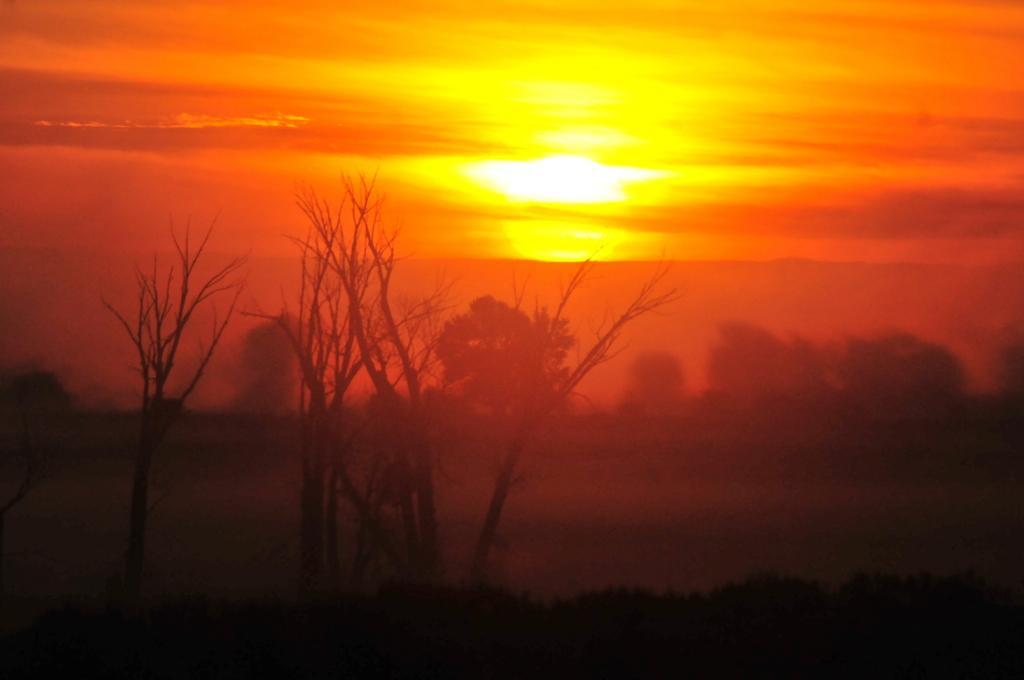How would you summarize this image in a sentence or two? In this image I can see number of trees, the sky and the sun. I can also see this image is orange in colour. 